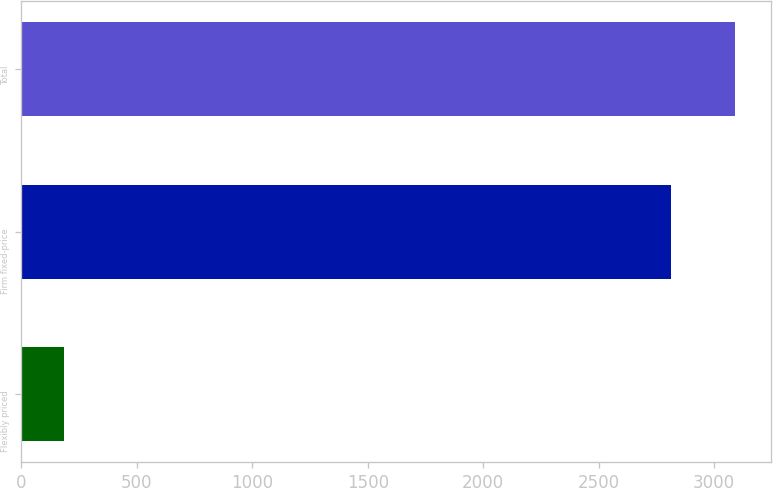Convert chart. <chart><loc_0><loc_0><loc_500><loc_500><bar_chart><fcel>Flexibly priced<fcel>Firm fixed-price<fcel>Total<nl><fcel>184<fcel>2811<fcel>3092.1<nl></chart> 